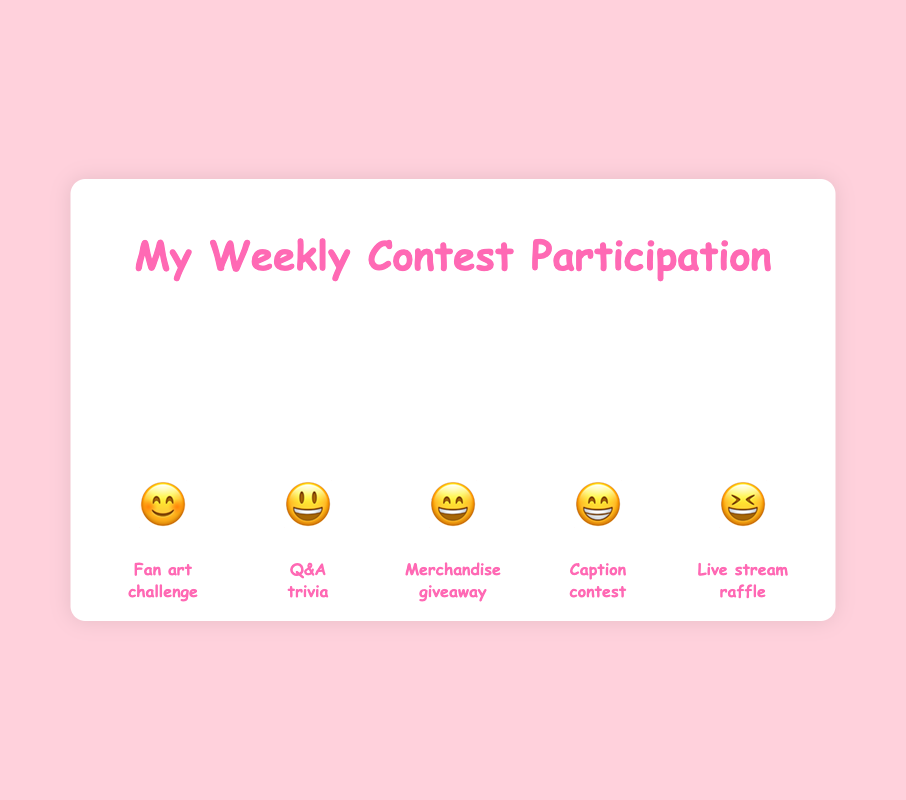How often do I participate in the Fan art challenge each week and which emoji is used to represent it? The Fan art challenge is represented by the first bar with the emoji 😊. Based on the height of the frequency bar, it corresponds to a frequency of 1.
Answer: 1, 😊 Which contest type has the highest participation frequency and what is the corresponding emoji? The tallest bar has the emoji 😆 and represents the Live stream raffle. The height indicates the highest frequency, which is 5.
Answer: Live stream raffle, 😆 Compare my participation frequency in the Q&A trivia and Caption contest. Which one do I participate in more frequently? The Q&A trivia bar shows the emoji 😃 with a frequency of 2, while the Caption contest bar shows the emoji 😁 with a frequency of 4. The Caption contest has a higher frequency.
Answer: Caption contest How much more frequently do I participate in the Merchandise giveaway compared to the Fan art challenge? The Merchandise giveaway bar, represented by 😄, has a frequency of 3. The Fan art challenge bar, represented by 😊, has a frequency of 1. The difference is 3 - 1 = 2.
Answer: 2 What's the average participation frequency across all contest types? Sum all frequencies: 1 (Fan art challenge) + 2 (Q&A trivia) + 3 (Merchandise giveaway) + 4 (Caption contest) + 5 (Live stream raffle) = 15. There are 5 contest types, so the average is 15 / 5 = 3.
Answer: 3 Determine the median participation frequency of all the contests. Arrange the frequencies in ascending order: 1, 2, 3, 4, 5. The middle value is the third one, which is 3.
Answer: 3 What is the total participation frequency for the Q&A trivia and Live stream raffle combined? The Q&A trivia frequency is 2 and the Live stream raffle frequency is 5. Adding these gives 2 + 5 = 7.
Answer: 7 Which contest type has the lowest frequency of participation and what is the corresponding emoji? The shortest bar is for the Fan art challenge, represented by 😊, and has a frequency of 1.
Answer: Fan art challenge, 😊 How does the participation frequency for Merchandise giveaway compare to the Live stream raffle? The frequency for the Merchandise giveaway (😄) is 3, while for the Live stream raffle (😆) it is 5. The Live stream raffle’s frequency is higher.
Answer: Live stream raffle has a higher frequency 